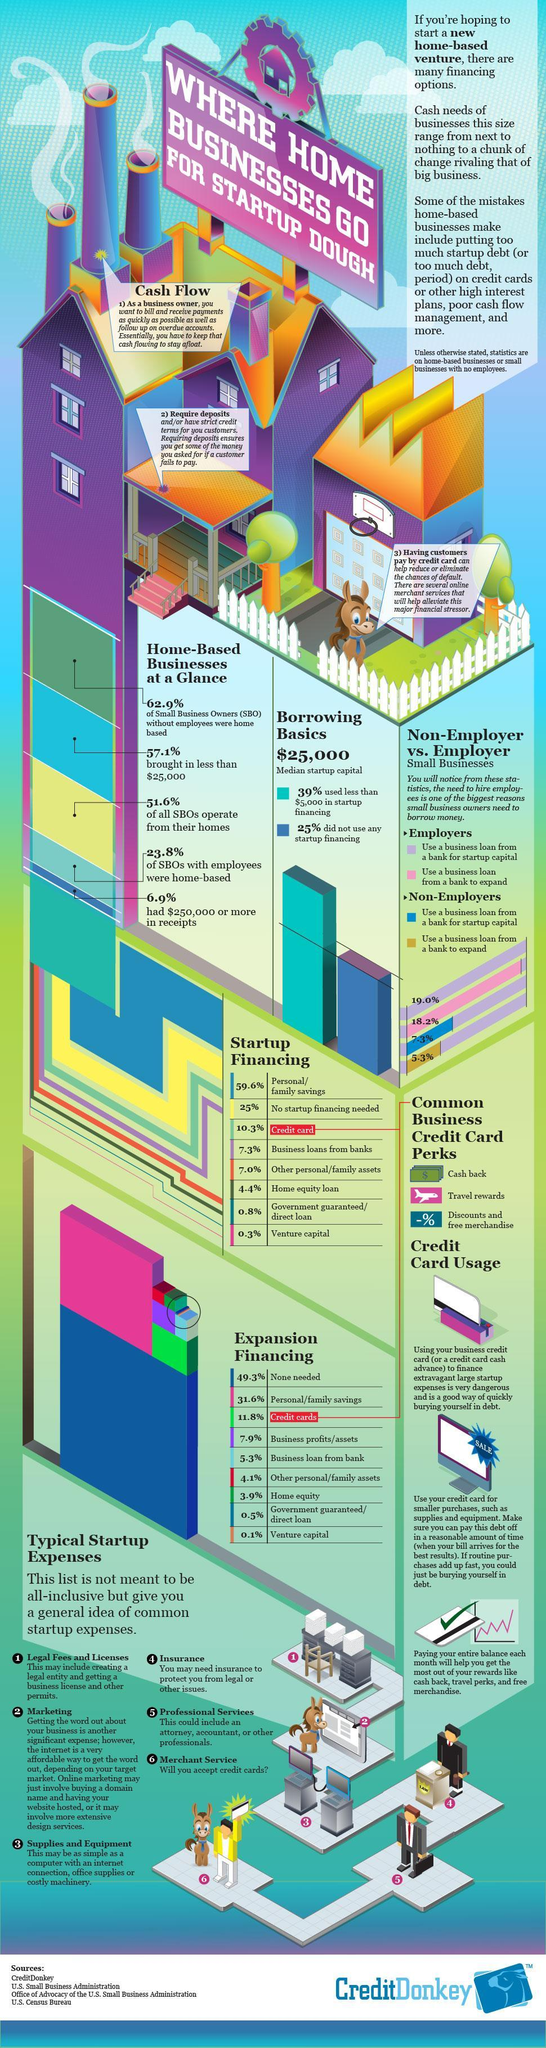What percentage of all SBOs are not working from home?
Answer the question with a short phrase. 48.4 What percentage of SBOs with employees are not home based? 76.2 What percentage of SBOs took less than $250,000 for startup financing? 93.1 What percentage of SBOs took more than $25,000 for startup financing? 42.9 How many advantages of Credit cards are listed in the info graphic? 3 Which is the second advantage of Credit card usage as mentioned in the info graphic? Travel Rewards What percentage of SBOs without employees are not home based? 37.1 